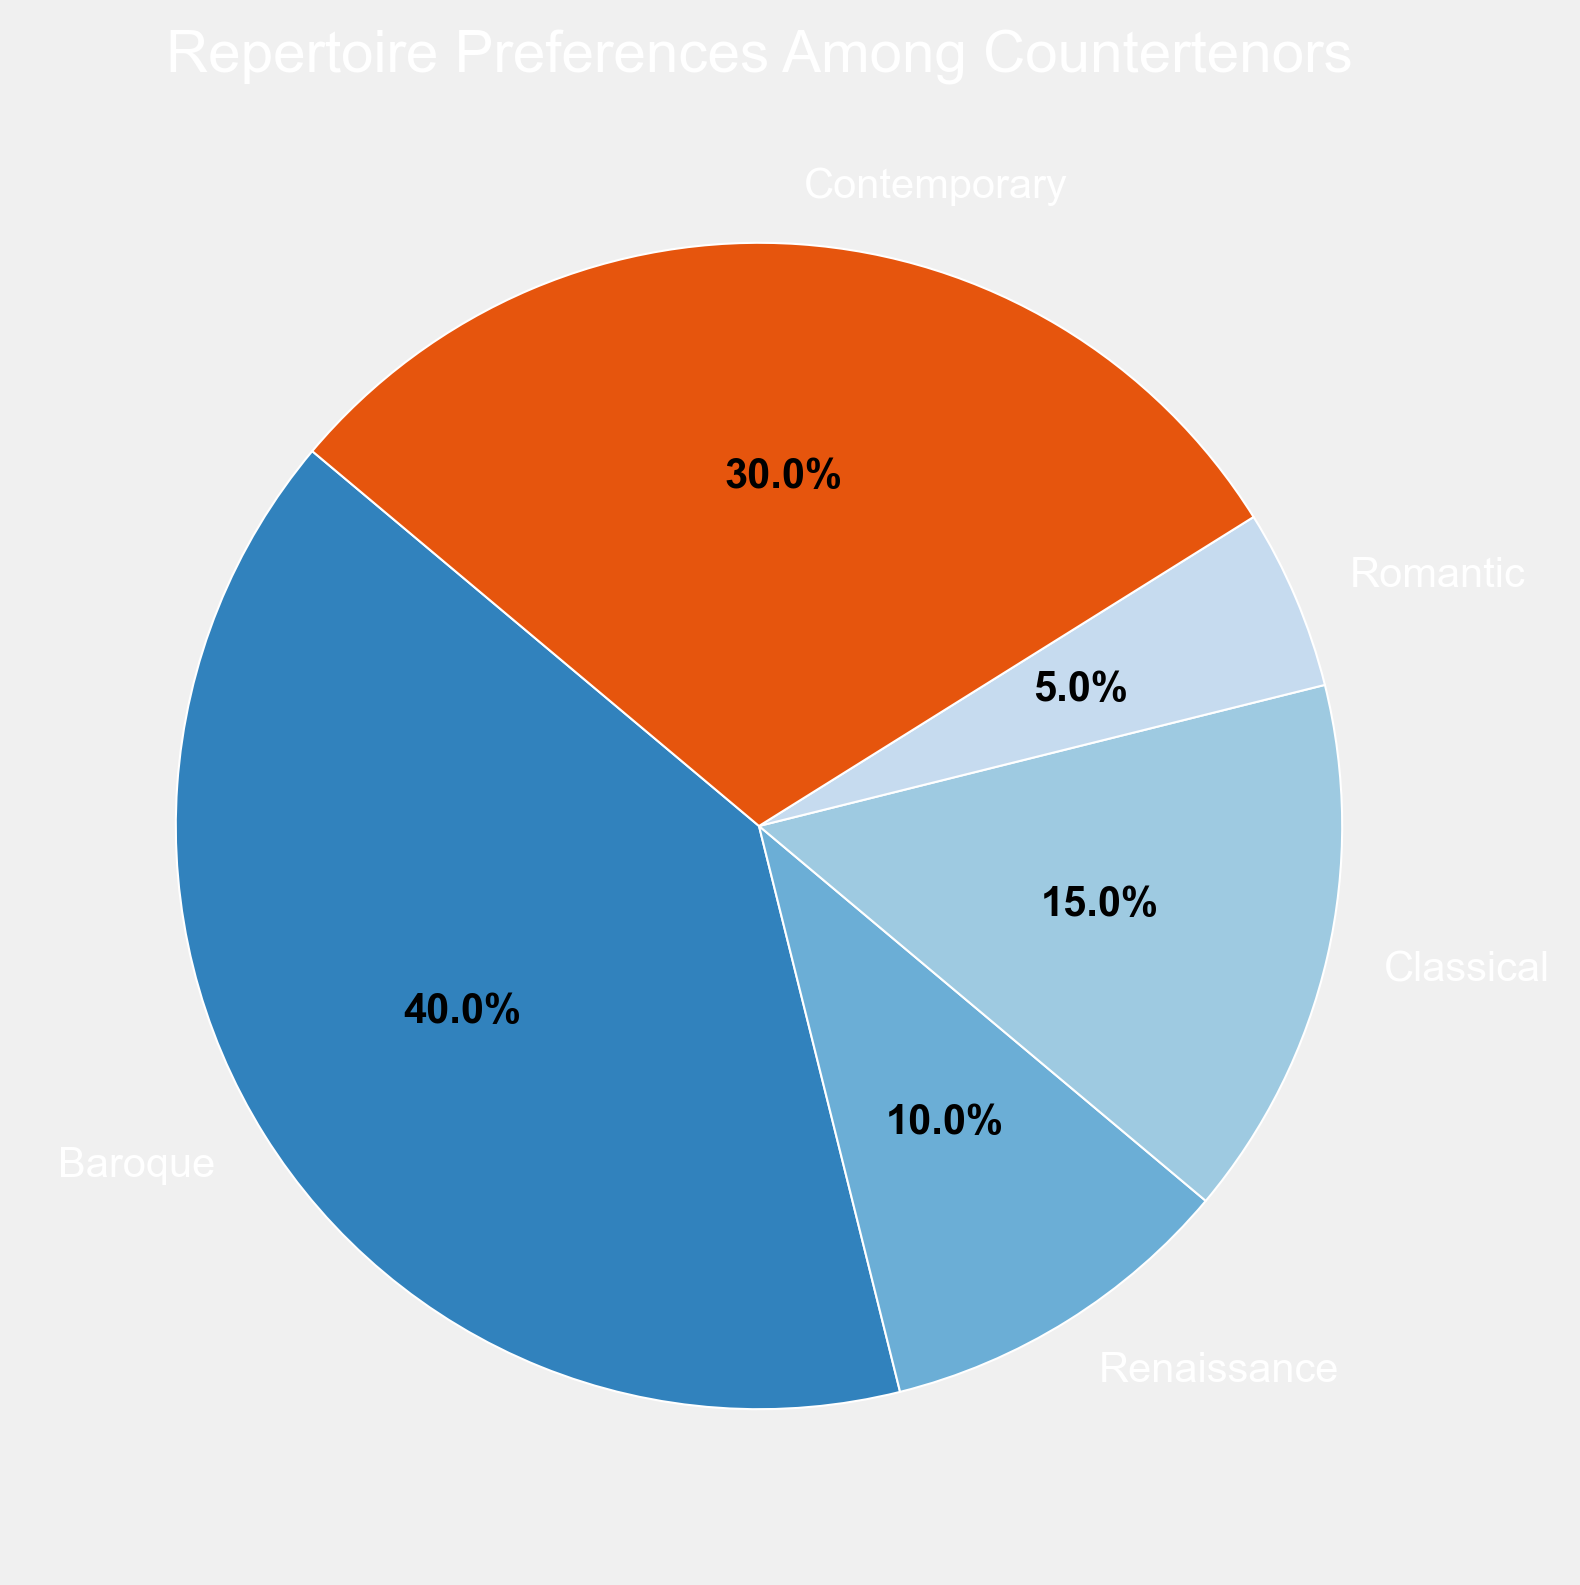What percentage of countertenors prefer Baroque repertoire? Look at the section labeled "Baroque" on the pie chart and read the percentage presented.
Answer: 40% How much larger is the Contemporary preference compared to the Renaissance preference? Find the percentages for Contemporary and Renaissance from the chart (30% and 10%, respectively) and subtract the Renaissance preference from the Contemporary preference. 30 - 10 = 20
Answer: 20% What are the three most preferred musical eras among countertenors? Identify the three largest sections of the pie chart and note their labels.
Answer: Baroque, Contemporary, Classical Which musical era has the smallest percentage of repertoire preference among countertenors? Find the smallest segment in the pie chart and read its label.
Answer: Romantic Are the preferences for Classical and Romantic eras combined greater than the preference for Contemporary? Add the percentages for Classical and Romantic (15% + 5%) and compare the sum (20%) with the percentage for Contemporary (30%). 20% < 30%.
Answer: No What is the total percentage of countertenors preferring either Baroque or Renaissance repertoires? Add the percentages for Baroque and Renaissance (40% + 10%). 40 + 10 = 50
Answer: 50% How much smaller is the Renaissance preference compared to the Classical preference? Subtract the Renaissance percentage from the Classical percentage (15% - 10%). 15 - 10 = 5
Answer: 5% What are the colors used to represent the Baroque, Renaissance, and Contemporary eras in the chart? Observe the colors assigned to the segments for Baroque, Renaissance, and Contemporary in the pie chart.
Answer: Orange, light blue, muted green Which two eras have preferences that together account for half of the total preferences? Identify pairs of eras that together sum up to 50%. Baroque and Renaissance (40% + 10%).
Answer: Baroque and Renaissance By how much does the sum of the preferences for Baroque and Contemporary exceed the total preferences for Classical and Romantic eras? Add the percentages for Baroque and Contemporary (40% + 30%) and for Classical and Romantic (15% + 5%). Subtract the total for Classical and Romantic from the total for Baroque and Contemporary (70% - 20%), resulting in 50%.
Answer: 50% 